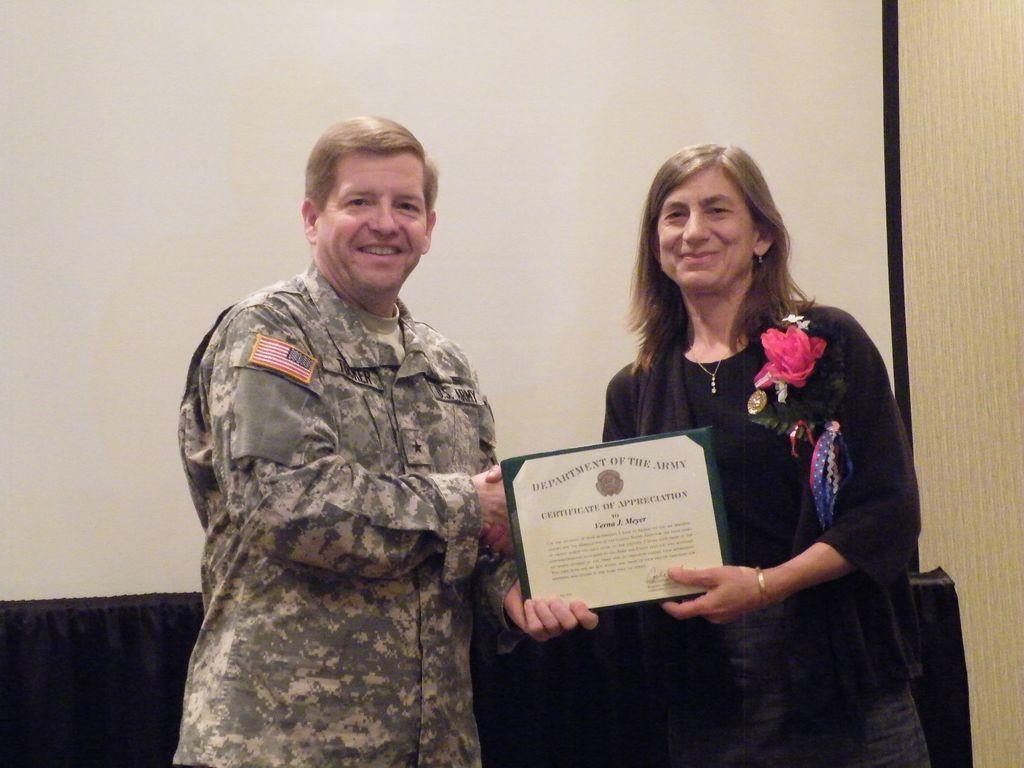Can you describe this image briefly? In the image there are two people, both of them are laughing and they are holding an award together and in the background it seems like there is a projector screen. 